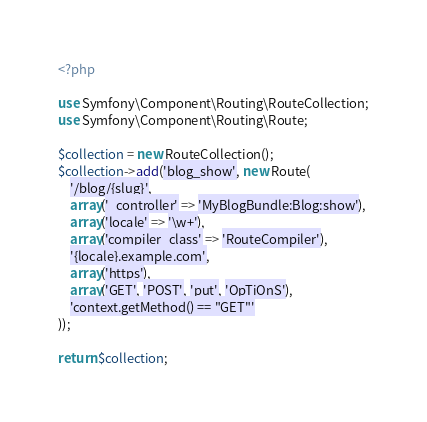Convert code to text. <code><loc_0><loc_0><loc_500><loc_500><_PHP_><?php

use Symfony\Component\Routing\RouteCollection;
use Symfony\Component\Routing\Route;

$collection = new RouteCollection();
$collection->add('blog_show', new Route(
    '/blog/{slug}',
    array('_controller' => 'MyBlogBundle:Blog:show'),
    array('locale' => '\w+'),
    array('compiler_class' => 'RouteCompiler'),
    '{locale}.example.com',
    array('https'),
    array('GET', 'POST', 'put', 'OpTiOnS'),
    'context.getMethod() == "GET"'
));

return $collection;
</code> 